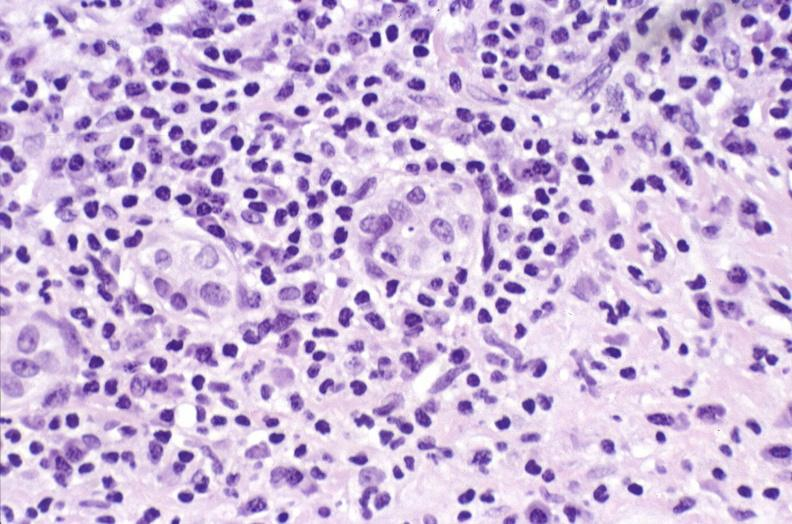s supernumerary digits present?
Answer the question using a single word or phrase. No 